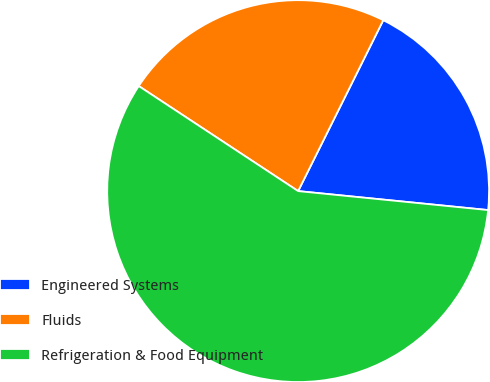Convert chart to OTSL. <chart><loc_0><loc_0><loc_500><loc_500><pie_chart><fcel>Engineered Systems<fcel>Fluids<fcel>Refrigeration & Food Equipment<nl><fcel>19.23%<fcel>23.08%<fcel>57.69%<nl></chart> 